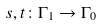<formula> <loc_0><loc_0><loc_500><loc_500>s , t \colon \Gamma _ { 1 } \to \Gamma _ { 0 }</formula> 